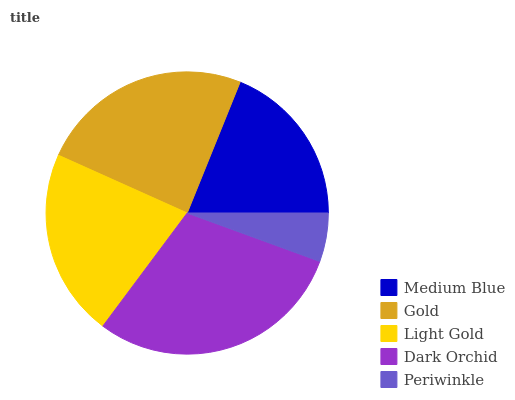Is Periwinkle the minimum?
Answer yes or no. Yes. Is Dark Orchid the maximum?
Answer yes or no. Yes. Is Gold the minimum?
Answer yes or no. No. Is Gold the maximum?
Answer yes or no. No. Is Gold greater than Medium Blue?
Answer yes or no. Yes. Is Medium Blue less than Gold?
Answer yes or no. Yes. Is Medium Blue greater than Gold?
Answer yes or no. No. Is Gold less than Medium Blue?
Answer yes or no. No. Is Light Gold the high median?
Answer yes or no. Yes. Is Light Gold the low median?
Answer yes or no. Yes. Is Dark Orchid the high median?
Answer yes or no. No. Is Medium Blue the low median?
Answer yes or no. No. 